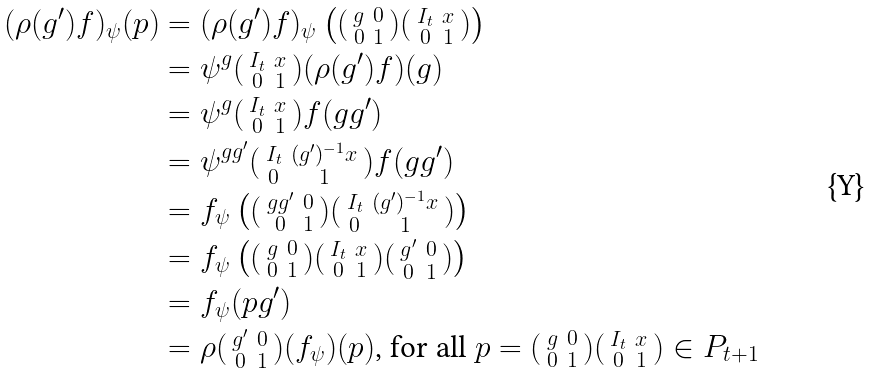Convert formula to latex. <formula><loc_0><loc_0><loc_500><loc_500>( \rho ( g ^ { \prime } ) f ) _ { \psi } ( p ) & = ( \rho ( g ^ { \prime } ) f ) _ { \psi } \left ( ( \begin{smallmatrix} g & 0 \\ 0 & 1 \end{smallmatrix} ) ( \begin{smallmatrix} I _ { t } & x \\ 0 & 1 \end{smallmatrix} ) \right ) \\ & = \psi ^ { g } ( \begin{smallmatrix} I _ { t } & x \\ 0 & 1 \end{smallmatrix} ) ( \rho ( g ^ { \prime } ) f ) ( g ) \\ & = \psi ^ { g } ( \begin{smallmatrix} I _ { t } & x \\ 0 & 1 \end{smallmatrix} ) f ( g g ^ { \prime } ) \\ & = \psi ^ { g g ^ { \prime } } ( \begin{smallmatrix} I _ { t } & ( g ^ { \prime } ) ^ { - 1 } x \\ 0 & 1 \end{smallmatrix} ) f ( g g ^ { \prime } ) \\ & = f _ { \psi } \left ( ( \begin{smallmatrix} g g ^ { \prime } & 0 \\ 0 & 1 \end{smallmatrix} ) ( \begin{smallmatrix} I _ { t } & ( g ^ { \prime } ) ^ { - 1 } x \\ 0 & 1 \end{smallmatrix} ) \right ) \\ & = f _ { \psi } \left ( ( \begin{smallmatrix} g & 0 \\ 0 & 1 \end{smallmatrix} ) ( \begin{smallmatrix} I _ { t } & x \\ 0 & 1 \end{smallmatrix} ) ( \begin{smallmatrix} g ^ { \prime } & 0 \\ 0 & 1 \end{smallmatrix} ) \right ) \\ & = f _ { \psi } ( p g ^ { \prime } ) \\ & = \rho ( \begin{smallmatrix} g ^ { \prime } & 0 \\ 0 & 1 \end{smallmatrix} ) ( f _ { \psi } ) ( p ) \text {, for all } p = ( \begin{smallmatrix} g & 0 \\ 0 & 1 \end{smallmatrix} ) ( \begin{smallmatrix} I _ { t } & x \\ 0 & 1 \end{smallmatrix} ) \in P _ { t + 1 }</formula> 